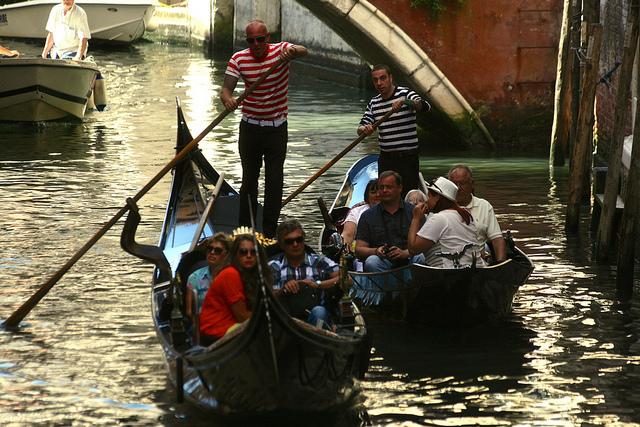What color is the closest women's shirt?
Be succinct. Red. Are these canoes overcrowded?
Write a very short answer. Yes. How many boats?
Answer briefly. 4. 